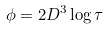<formula> <loc_0><loc_0><loc_500><loc_500>\phi = 2 D ^ { 3 } \log { \tau }</formula> 